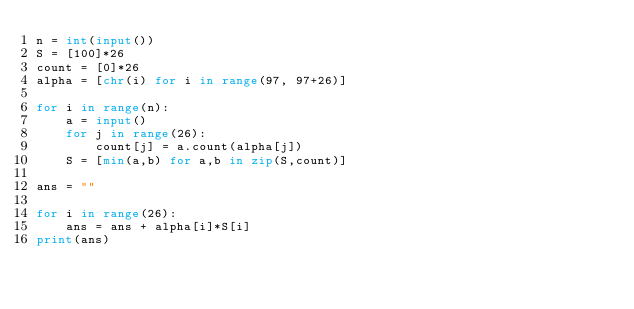<code> <loc_0><loc_0><loc_500><loc_500><_Python_>n = int(input())
S = [100]*26
count = [0]*26
alpha = [chr(i) for i in range(97, 97+26)]

for i in range(n):
    a = input()
    for j in range(26):
        count[j] = a.count(alpha[j])
    S = [min(a,b) for a,b in zip(S,count)]

ans = ""

for i in range(26):
    ans = ans + alpha[i]*S[i]
print(ans)</code> 